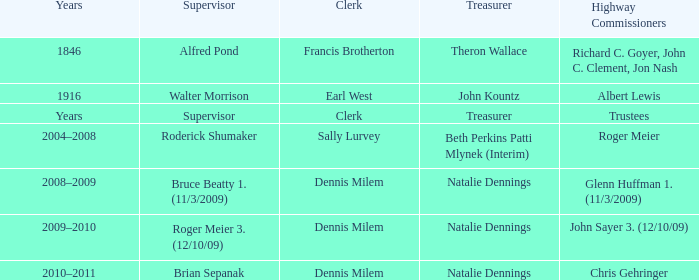When Treasurer was treasurer, who was the highway commissioner? Trustees. 